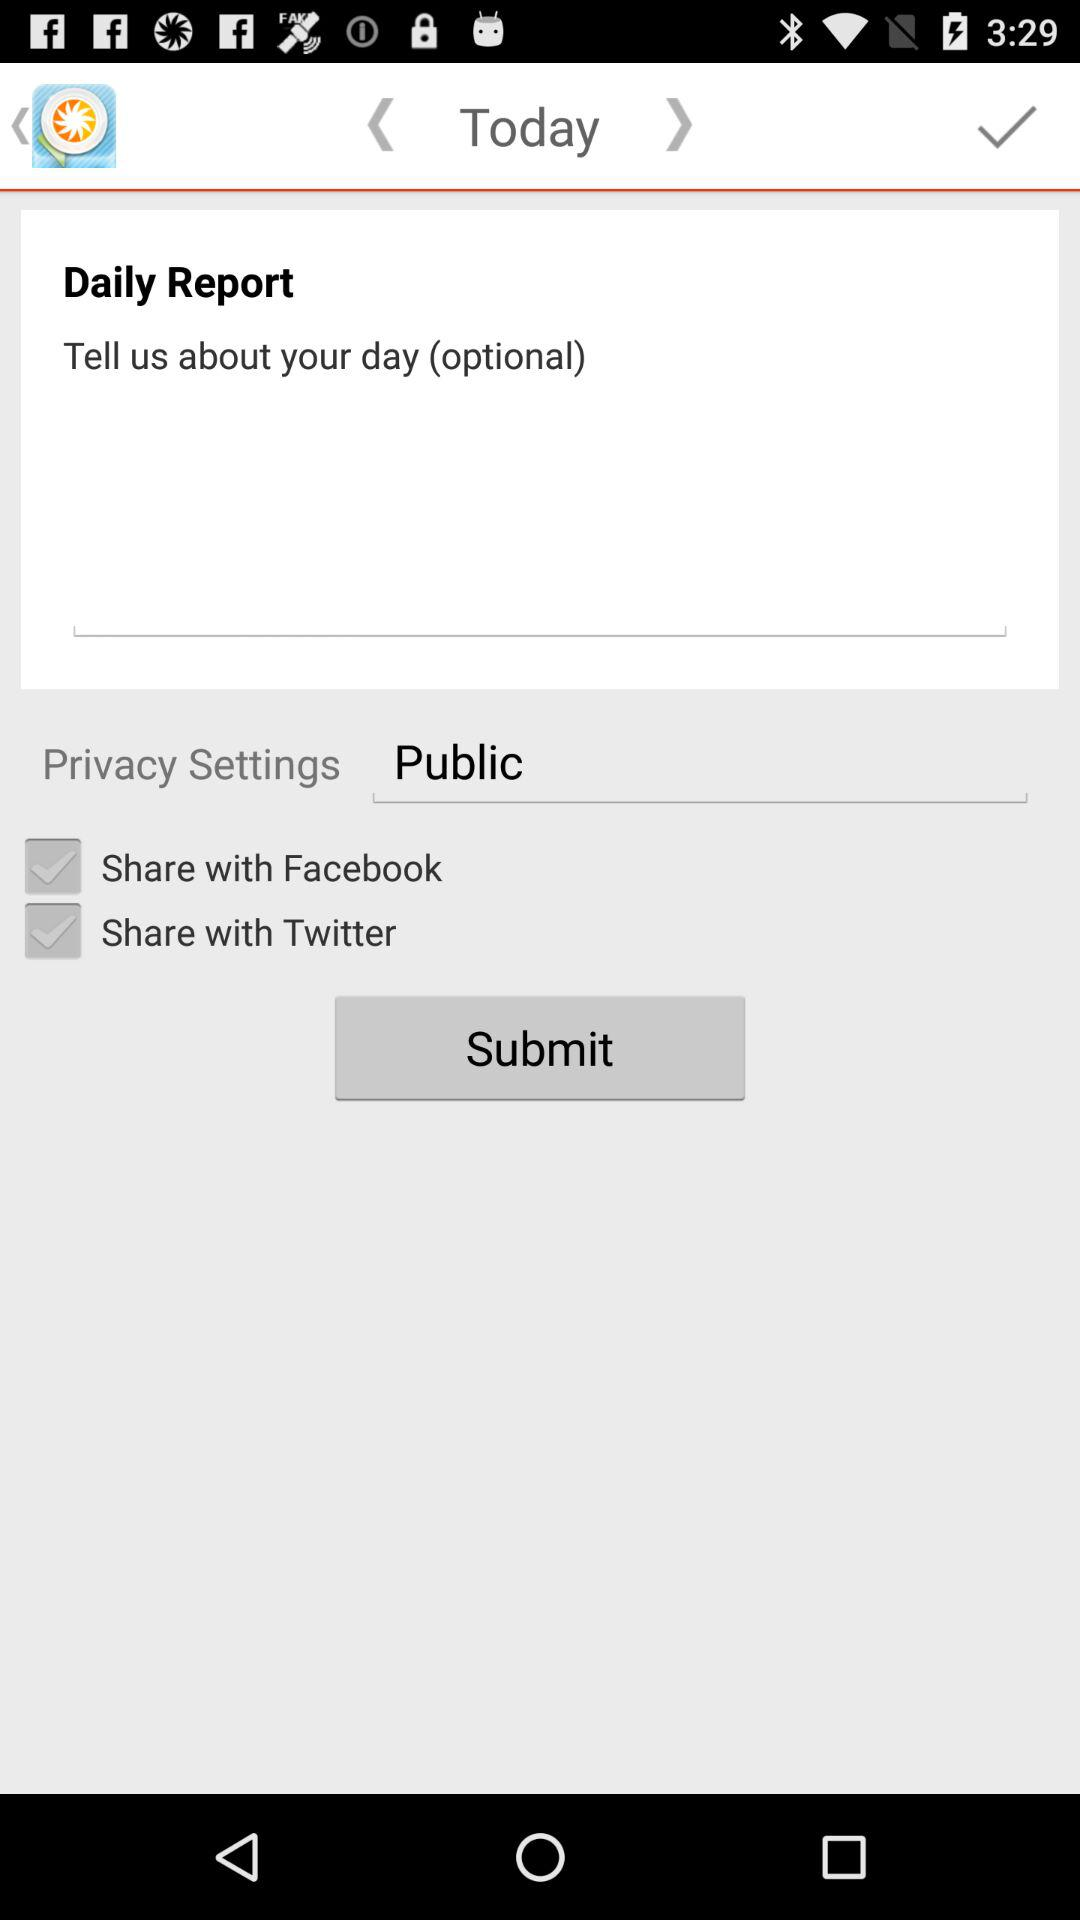What day is selected? The selected day is today. 